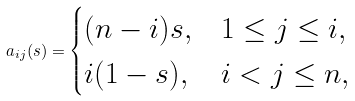<formula> <loc_0><loc_0><loc_500><loc_500>a _ { i j } ( s ) = \begin{cases} ( n - i ) s , & 1 \leq j \leq i , \\ i ( 1 - s ) , & i < j \leq n , \end{cases}</formula> 